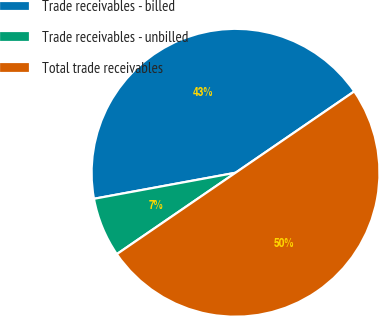Convert chart to OTSL. <chart><loc_0><loc_0><loc_500><loc_500><pie_chart><fcel>Trade receivables - billed<fcel>Trade receivables - unbilled<fcel>Total trade receivables<nl><fcel>43.33%<fcel>6.67%<fcel>50.0%<nl></chart> 